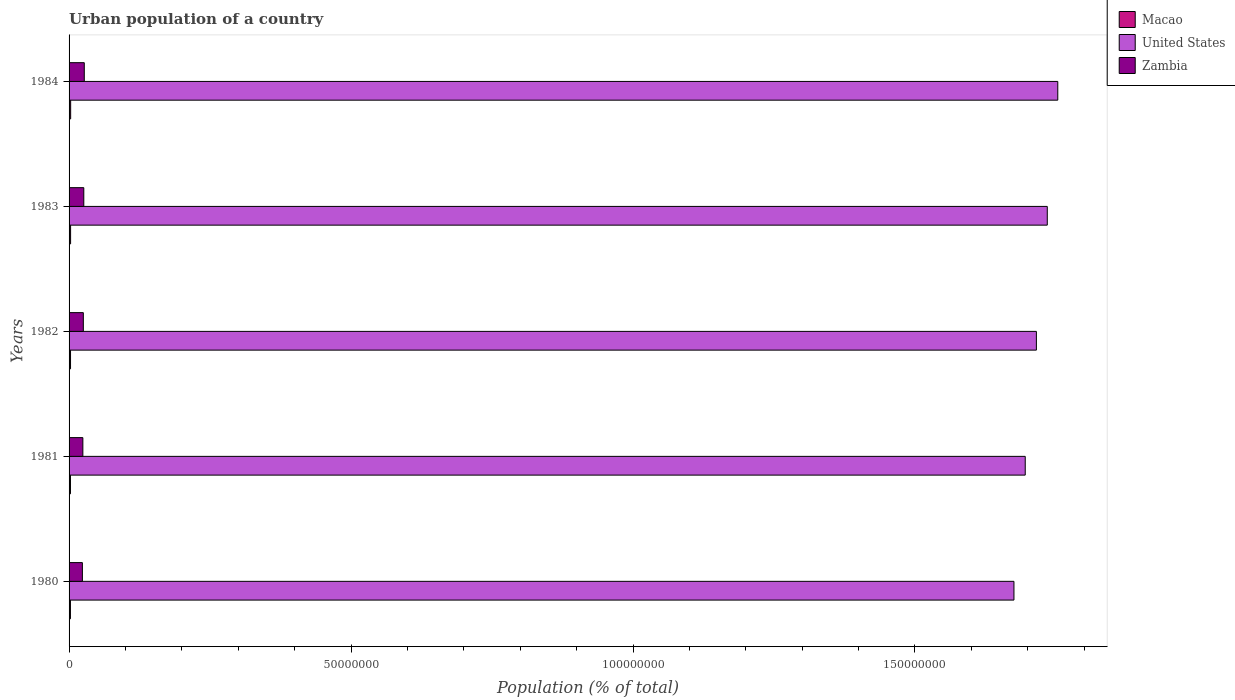How many groups of bars are there?
Provide a succinct answer. 5. Are the number of bars on each tick of the Y-axis equal?
Keep it short and to the point. Yes. How many bars are there on the 3rd tick from the top?
Offer a very short reply. 3. In how many cases, is the number of bars for a given year not equal to the number of legend labels?
Provide a succinct answer. 0. What is the urban population in Zambia in 1982?
Offer a very short reply. 2.53e+06. Across all years, what is the maximum urban population in United States?
Provide a succinct answer. 1.75e+08. Across all years, what is the minimum urban population in United States?
Your answer should be compact. 1.68e+08. What is the total urban population in Zambia in the graph?
Keep it short and to the point. 1.26e+07. What is the difference between the urban population in Zambia in 1980 and that in 1983?
Offer a very short reply. -2.52e+05. What is the difference between the urban population in Zambia in 1980 and the urban population in United States in 1983?
Provide a succinct answer. -1.71e+08. What is the average urban population in Macao per year?
Offer a very short reply. 2.60e+05. In the year 1981, what is the difference between the urban population in Macao and urban population in United States?
Offer a terse response. -1.69e+08. In how many years, is the urban population in Macao greater than 10000000 %?
Offer a terse response. 0. What is the ratio of the urban population in Zambia in 1980 to that in 1982?
Ensure brevity in your answer.  0.93. Is the urban population in Zambia in 1981 less than that in 1982?
Make the answer very short. Yes. What is the difference between the highest and the second highest urban population in Macao?
Provide a short and direct response. 1.23e+04. What is the difference between the highest and the lowest urban population in United States?
Provide a short and direct response. 7.77e+06. In how many years, is the urban population in Zambia greater than the average urban population in Zambia taken over all years?
Your answer should be very brief. 2. What does the 1st bar from the top in 1981 represents?
Your answer should be compact. Zambia. What does the 1st bar from the bottom in 1980 represents?
Offer a very short reply. Macao. Is it the case that in every year, the sum of the urban population in Zambia and urban population in Macao is greater than the urban population in United States?
Your answer should be compact. No. Does the graph contain grids?
Make the answer very short. No. How many legend labels are there?
Give a very brief answer. 3. How are the legend labels stacked?
Give a very brief answer. Vertical. What is the title of the graph?
Offer a very short reply. Urban population of a country. Does "Switzerland" appear as one of the legend labels in the graph?
Give a very brief answer. No. What is the label or title of the X-axis?
Keep it short and to the point. Population (% of total). What is the Population (% of total) of Macao in 1980?
Provide a short and direct response. 2.43e+05. What is the Population (% of total) of United States in 1980?
Provide a short and direct response. 1.68e+08. What is the Population (% of total) in Zambia in 1980?
Offer a terse response. 2.36e+06. What is the Population (% of total) of Macao in 1981?
Make the answer very short. 2.49e+05. What is the Population (% of total) in United States in 1981?
Offer a very short reply. 1.70e+08. What is the Population (% of total) in Zambia in 1981?
Provide a succinct answer. 2.45e+06. What is the Population (% of total) in Macao in 1982?
Your answer should be very brief. 2.58e+05. What is the Population (% of total) of United States in 1982?
Ensure brevity in your answer.  1.72e+08. What is the Population (% of total) of Zambia in 1982?
Your answer should be compact. 2.53e+06. What is the Population (% of total) of Macao in 1983?
Keep it short and to the point. 2.69e+05. What is the Population (% of total) of United States in 1983?
Your response must be concise. 1.73e+08. What is the Population (% of total) of Zambia in 1983?
Your answer should be compact. 2.61e+06. What is the Population (% of total) in Macao in 1984?
Offer a very short reply. 2.82e+05. What is the Population (% of total) of United States in 1984?
Give a very brief answer. 1.75e+08. What is the Population (% of total) in Zambia in 1984?
Make the answer very short. 2.70e+06. Across all years, what is the maximum Population (% of total) of Macao?
Your response must be concise. 2.82e+05. Across all years, what is the maximum Population (% of total) of United States?
Offer a terse response. 1.75e+08. Across all years, what is the maximum Population (% of total) in Zambia?
Provide a short and direct response. 2.70e+06. Across all years, what is the minimum Population (% of total) of Macao?
Ensure brevity in your answer.  2.43e+05. Across all years, what is the minimum Population (% of total) in United States?
Your answer should be very brief. 1.68e+08. Across all years, what is the minimum Population (% of total) of Zambia?
Make the answer very short. 2.36e+06. What is the total Population (% of total) in Macao in the graph?
Keep it short and to the point. 1.30e+06. What is the total Population (% of total) of United States in the graph?
Your answer should be very brief. 8.57e+08. What is the total Population (% of total) of Zambia in the graph?
Make the answer very short. 1.26e+07. What is the difference between the Population (% of total) of Macao in 1980 and that in 1981?
Your response must be concise. -6276. What is the difference between the Population (% of total) in United States in 1980 and that in 1981?
Your answer should be very brief. -2.00e+06. What is the difference between the Population (% of total) in Zambia in 1980 and that in 1981?
Provide a succinct answer. -8.54e+04. What is the difference between the Population (% of total) of Macao in 1980 and that in 1982?
Ensure brevity in your answer.  -1.54e+04. What is the difference between the Population (% of total) in United States in 1980 and that in 1982?
Your answer should be compact. -3.98e+06. What is the difference between the Population (% of total) of Zambia in 1980 and that in 1982?
Your answer should be very brief. -1.68e+05. What is the difference between the Population (% of total) in Macao in 1980 and that in 1983?
Your answer should be compact. -2.66e+04. What is the difference between the Population (% of total) of United States in 1980 and that in 1983?
Your answer should be very brief. -5.91e+06. What is the difference between the Population (% of total) in Zambia in 1980 and that in 1983?
Your answer should be very brief. -2.52e+05. What is the difference between the Population (% of total) in Macao in 1980 and that in 1984?
Give a very brief answer. -3.89e+04. What is the difference between the Population (% of total) of United States in 1980 and that in 1984?
Keep it short and to the point. -7.77e+06. What is the difference between the Population (% of total) of Zambia in 1980 and that in 1984?
Your answer should be compact. -3.37e+05. What is the difference between the Population (% of total) in Macao in 1981 and that in 1982?
Keep it short and to the point. -9157. What is the difference between the Population (% of total) of United States in 1981 and that in 1982?
Your answer should be very brief. -1.98e+06. What is the difference between the Population (% of total) in Zambia in 1981 and that in 1982?
Provide a short and direct response. -8.24e+04. What is the difference between the Population (% of total) of Macao in 1981 and that in 1983?
Give a very brief answer. -2.03e+04. What is the difference between the Population (% of total) of United States in 1981 and that in 1983?
Your answer should be compact. -3.91e+06. What is the difference between the Population (% of total) in Zambia in 1981 and that in 1983?
Ensure brevity in your answer.  -1.66e+05. What is the difference between the Population (% of total) of Macao in 1981 and that in 1984?
Your answer should be very brief. -3.27e+04. What is the difference between the Population (% of total) in United States in 1981 and that in 1984?
Your answer should be very brief. -5.77e+06. What is the difference between the Population (% of total) of Zambia in 1981 and that in 1984?
Offer a very short reply. -2.51e+05. What is the difference between the Population (% of total) in Macao in 1982 and that in 1983?
Provide a short and direct response. -1.12e+04. What is the difference between the Population (% of total) in United States in 1982 and that in 1983?
Ensure brevity in your answer.  -1.93e+06. What is the difference between the Population (% of total) of Zambia in 1982 and that in 1983?
Provide a succinct answer. -8.39e+04. What is the difference between the Population (% of total) in Macao in 1982 and that in 1984?
Your response must be concise. -2.35e+04. What is the difference between the Population (% of total) of United States in 1982 and that in 1984?
Your answer should be very brief. -3.79e+06. What is the difference between the Population (% of total) in Zambia in 1982 and that in 1984?
Ensure brevity in your answer.  -1.69e+05. What is the difference between the Population (% of total) in Macao in 1983 and that in 1984?
Keep it short and to the point. -1.23e+04. What is the difference between the Population (% of total) in United States in 1983 and that in 1984?
Offer a very short reply. -1.86e+06. What is the difference between the Population (% of total) in Zambia in 1983 and that in 1984?
Offer a very short reply. -8.49e+04. What is the difference between the Population (% of total) of Macao in 1980 and the Population (% of total) of United States in 1981?
Provide a succinct answer. -1.69e+08. What is the difference between the Population (% of total) of Macao in 1980 and the Population (% of total) of Zambia in 1981?
Give a very brief answer. -2.20e+06. What is the difference between the Population (% of total) in United States in 1980 and the Population (% of total) in Zambia in 1981?
Make the answer very short. 1.65e+08. What is the difference between the Population (% of total) in Macao in 1980 and the Population (% of total) in United States in 1982?
Offer a terse response. -1.71e+08. What is the difference between the Population (% of total) in Macao in 1980 and the Population (% of total) in Zambia in 1982?
Your answer should be very brief. -2.29e+06. What is the difference between the Population (% of total) of United States in 1980 and the Population (% of total) of Zambia in 1982?
Give a very brief answer. 1.65e+08. What is the difference between the Population (% of total) in Macao in 1980 and the Population (% of total) in United States in 1983?
Keep it short and to the point. -1.73e+08. What is the difference between the Population (% of total) of Macao in 1980 and the Population (% of total) of Zambia in 1983?
Make the answer very short. -2.37e+06. What is the difference between the Population (% of total) in United States in 1980 and the Population (% of total) in Zambia in 1983?
Your answer should be compact. 1.65e+08. What is the difference between the Population (% of total) in Macao in 1980 and the Population (% of total) in United States in 1984?
Your answer should be very brief. -1.75e+08. What is the difference between the Population (% of total) of Macao in 1980 and the Population (% of total) of Zambia in 1984?
Provide a short and direct response. -2.45e+06. What is the difference between the Population (% of total) in United States in 1980 and the Population (% of total) in Zambia in 1984?
Provide a short and direct response. 1.65e+08. What is the difference between the Population (% of total) in Macao in 1981 and the Population (% of total) in United States in 1982?
Provide a succinct answer. -1.71e+08. What is the difference between the Population (% of total) in Macao in 1981 and the Population (% of total) in Zambia in 1982?
Your response must be concise. -2.28e+06. What is the difference between the Population (% of total) in United States in 1981 and the Population (% of total) in Zambia in 1982?
Offer a very short reply. 1.67e+08. What is the difference between the Population (% of total) in Macao in 1981 and the Population (% of total) in United States in 1983?
Your answer should be very brief. -1.73e+08. What is the difference between the Population (% of total) in Macao in 1981 and the Population (% of total) in Zambia in 1983?
Ensure brevity in your answer.  -2.36e+06. What is the difference between the Population (% of total) of United States in 1981 and the Population (% of total) of Zambia in 1983?
Provide a short and direct response. 1.67e+08. What is the difference between the Population (% of total) of Macao in 1981 and the Population (% of total) of United States in 1984?
Give a very brief answer. -1.75e+08. What is the difference between the Population (% of total) of Macao in 1981 and the Population (% of total) of Zambia in 1984?
Provide a succinct answer. -2.45e+06. What is the difference between the Population (% of total) of United States in 1981 and the Population (% of total) of Zambia in 1984?
Offer a terse response. 1.67e+08. What is the difference between the Population (% of total) in Macao in 1982 and the Population (% of total) in United States in 1983?
Your answer should be very brief. -1.73e+08. What is the difference between the Population (% of total) of Macao in 1982 and the Population (% of total) of Zambia in 1983?
Ensure brevity in your answer.  -2.35e+06. What is the difference between the Population (% of total) of United States in 1982 and the Population (% of total) of Zambia in 1983?
Your answer should be compact. 1.69e+08. What is the difference between the Population (% of total) in Macao in 1982 and the Population (% of total) in United States in 1984?
Offer a very short reply. -1.75e+08. What is the difference between the Population (% of total) of Macao in 1982 and the Population (% of total) of Zambia in 1984?
Provide a short and direct response. -2.44e+06. What is the difference between the Population (% of total) of United States in 1982 and the Population (% of total) of Zambia in 1984?
Offer a very short reply. 1.69e+08. What is the difference between the Population (% of total) in Macao in 1983 and the Population (% of total) in United States in 1984?
Provide a short and direct response. -1.75e+08. What is the difference between the Population (% of total) in Macao in 1983 and the Population (% of total) in Zambia in 1984?
Provide a short and direct response. -2.43e+06. What is the difference between the Population (% of total) of United States in 1983 and the Population (% of total) of Zambia in 1984?
Your answer should be compact. 1.71e+08. What is the average Population (% of total) of Macao per year?
Your answer should be compact. 2.60e+05. What is the average Population (% of total) of United States per year?
Your response must be concise. 1.71e+08. What is the average Population (% of total) in Zambia per year?
Ensure brevity in your answer.  2.53e+06. In the year 1980, what is the difference between the Population (% of total) of Macao and Population (% of total) of United States?
Your answer should be compact. -1.67e+08. In the year 1980, what is the difference between the Population (% of total) of Macao and Population (% of total) of Zambia?
Provide a succinct answer. -2.12e+06. In the year 1980, what is the difference between the Population (% of total) of United States and Population (% of total) of Zambia?
Your response must be concise. 1.65e+08. In the year 1981, what is the difference between the Population (% of total) of Macao and Population (% of total) of United States?
Make the answer very short. -1.69e+08. In the year 1981, what is the difference between the Population (% of total) in Macao and Population (% of total) in Zambia?
Provide a short and direct response. -2.20e+06. In the year 1981, what is the difference between the Population (% of total) of United States and Population (% of total) of Zambia?
Your answer should be very brief. 1.67e+08. In the year 1982, what is the difference between the Population (% of total) of Macao and Population (% of total) of United States?
Your answer should be very brief. -1.71e+08. In the year 1982, what is the difference between the Population (% of total) of Macao and Population (% of total) of Zambia?
Keep it short and to the point. -2.27e+06. In the year 1982, what is the difference between the Population (% of total) in United States and Population (% of total) in Zambia?
Give a very brief answer. 1.69e+08. In the year 1983, what is the difference between the Population (% of total) in Macao and Population (% of total) in United States?
Make the answer very short. -1.73e+08. In the year 1983, what is the difference between the Population (% of total) in Macao and Population (% of total) in Zambia?
Provide a succinct answer. -2.34e+06. In the year 1983, what is the difference between the Population (% of total) of United States and Population (% of total) of Zambia?
Provide a short and direct response. 1.71e+08. In the year 1984, what is the difference between the Population (% of total) of Macao and Population (% of total) of United States?
Offer a very short reply. -1.75e+08. In the year 1984, what is the difference between the Population (% of total) in Macao and Population (% of total) in Zambia?
Make the answer very short. -2.42e+06. In the year 1984, what is the difference between the Population (% of total) of United States and Population (% of total) of Zambia?
Make the answer very short. 1.73e+08. What is the ratio of the Population (% of total) in Macao in 1980 to that in 1981?
Offer a very short reply. 0.97. What is the ratio of the Population (% of total) of United States in 1980 to that in 1981?
Your answer should be very brief. 0.99. What is the ratio of the Population (% of total) of Zambia in 1980 to that in 1981?
Your answer should be compact. 0.97. What is the ratio of the Population (% of total) in Macao in 1980 to that in 1982?
Make the answer very short. 0.94. What is the ratio of the Population (% of total) in United States in 1980 to that in 1982?
Provide a succinct answer. 0.98. What is the ratio of the Population (% of total) in Zambia in 1980 to that in 1982?
Your answer should be very brief. 0.93. What is the ratio of the Population (% of total) of Macao in 1980 to that in 1983?
Offer a very short reply. 0.9. What is the ratio of the Population (% of total) in United States in 1980 to that in 1983?
Make the answer very short. 0.97. What is the ratio of the Population (% of total) in Zambia in 1980 to that in 1983?
Your answer should be compact. 0.9. What is the ratio of the Population (% of total) in Macao in 1980 to that in 1984?
Provide a short and direct response. 0.86. What is the ratio of the Population (% of total) of United States in 1980 to that in 1984?
Your answer should be compact. 0.96. What is the ratio of the Population (% of total) in Zambia in 1980 to that in 1984?
Keep it short and to the point. 0.88. What is the ratio of the Population (% of total) in Macao in 1981 to that in 1982?
Offer a terse response. 0.96. What is the ratio of the Population (% of total) in United States in 1981 to that in 1982?
Provide a short and direct response. 0.99. What is the ratio of the Population (% of total) in Zambia in 1981 to that in 1982?
Offer a very short reply. 0.97. What is the ratio of the Population (% of total) of Macao in 1981 to that in 1983?
Provide a succinct answer. 0.92. What is the ratio of the Population (% of total) in United States in 1981 to that in 1983?
Your answer should be very brief. 0.98. What is the ratio of the Population (% of total) of Zambia in 1981 to that in 1983?
Offer a terse response. 0.94. What is the ratio of the Population (% of total) in Macao in 1981 to that in 1984?
Give a very brief answer. 0.88. What is the ratio of the Population (% of total) in United States in 1981 to that in 1984?
Make the answer very short. 0.97. What is the ratio of the Population (% of total) in Zambia in 1981 to that in 1984?
Give a very brief answer. 0.91. What is the ratio of the Population (% of total) in Macao in 1982 to that in 1983?
Offer a terse response. 0.96. What is the ratio of the Population (% of total) in United States in 1982 to that in 1983?
Your response must be concise. 0.99. What is the ratio of the Population (% of total) of Zambia in 1982 to that in 1983?
Your answer should be very brief. 0.97. What is the ratio of the Population (% of total) in Macao in 1982 to that in 1984?
Provide a succinct answer. 0.92. What is the ratio of the Population (% of total) in United States in 1982 to that in 1984?
Make the answer very short. 0.98. What is the ratio of the Population (% of total) in Zambia in 1982 to that in 1984?
Provide a short and direct response. 0.94. What is the ratio of the Population (% of total) in Macao in 1983 to that in 1984?
Provide a short and direct response. 0.96. What is the ratio of the Population (% of total) of Zambia in 1983 to that in 1984?
Your answer should be very brief. 0.97. What is the difference between the highest and the second highest Population (% of total) of Macao?
Ensure brevity in your answer.  1.23e+04. What is the difference between the highest and the second highest Population (% of total) in United States?
Offer a terse response. 1.86e+06. What is the difference between the highest and the second highest Population (% of total) of Zambia?
Ensure brevity in your answer.  8.49e+04. What is the difference between the highest and the lowest Population (% of total) of Macao?
Your answer should be very brief. 3.89e+04. What is the difference between the highest and the lowest Population (% of total) in United States?
Your answer should be very brief. 7.77e+06. What is the difference between the highest and the lowest Population (% of total) in Zambia?
Provide a succinct answer. 3.37e+05. 